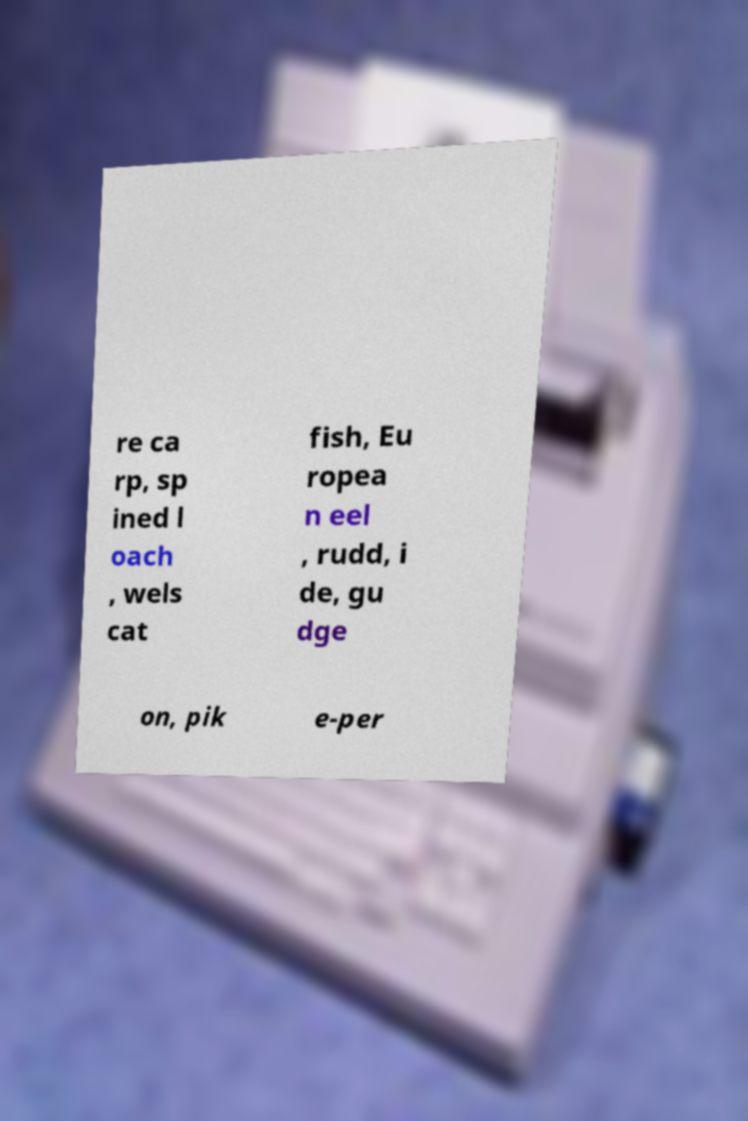Please read and relay the text visible in this image. What does it say? re ca rp, sp ined l oach , wels cat fish, Eu ropea n eel , rudd, i de, gu dge on, pik e-per 